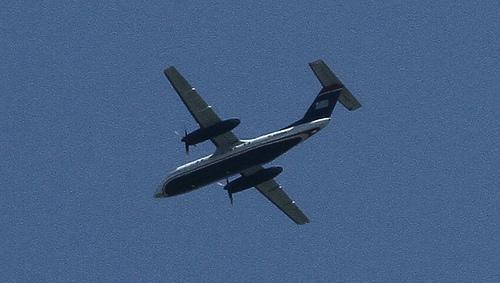How many engines does the plane have?
Give a very brief answer. 2. How many planes are there?
Give a very brief answer. 1. 